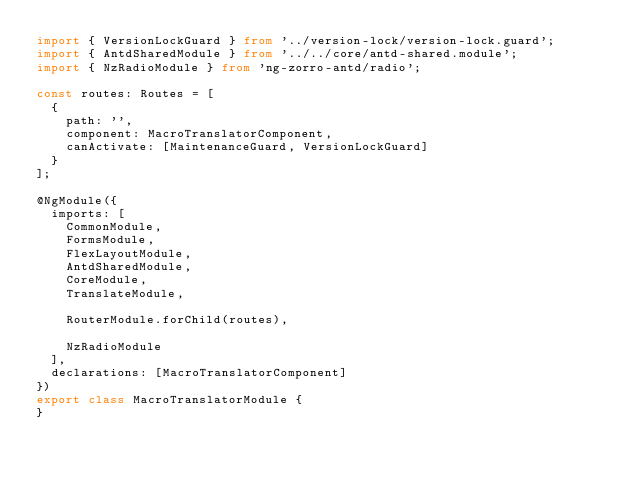Convert code to text. <code><loc_0><loc_0><loc_500><loc_500><_TypeScript_>import { VersionLockGuard } from '../version-lock/version-lock.guard';
import { AntdSharedModule } from '../../core/antd-shared.module';
import { NzRadioModule } from 'ng-zorro-antd/radio';

const routes: Routes = [
  {
    path: '',
    component: MacroTranslatorComponent,
    canActivate: [MaintenanceGuard, VersionLockGuard]
  }
];

@NgModule({
  imports: [
    CommonModule,
    FormsModule,
    FlexLayoutModule,
    AntdSharedModule,
    CoreModule,
    TranslateModule,

    RouterModule.forChild(routes),

    NzRadioModule
  ],
  declarations: [MacroTranslatorComponent]
})
export class MacroTranslatorModule {
}
</code> 